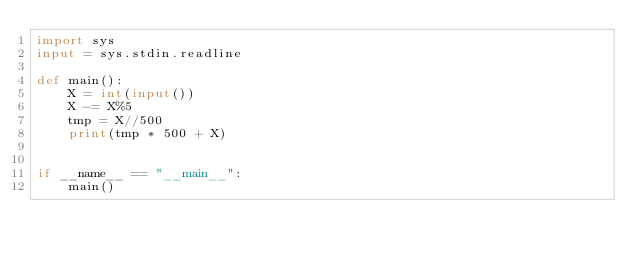<code> <loc_0><loc_0><loc_500><loc_500><_Python_>import sys
input = sys.stdin.readline

def main():
    X = int(input())
    X -= X%5
    tmp = X//500
    print(tmp * 500 + X)


if __name__ == "__main__":
    main()</code> 